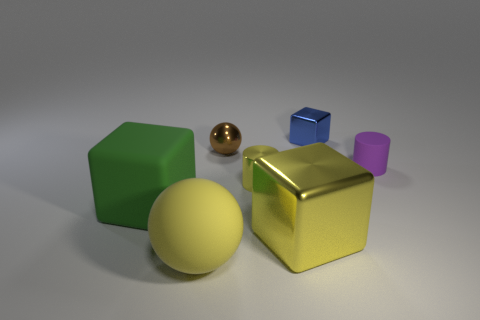What size is the ball that is the same material as the green cube?
Your answer should be compact. Large. Do the matte ball and the small shiny cylinder have the same color?
Ensure brevity in your answer.  Yes. There is a tiny thing behind the small brown metallic ball; is its shape the same as the big yellow shiny thing?
Your response must be concise. Yes. How many other gray blocks have the same size as the rubber cube?
Your answer should be very brief. 0. What is the shape of the matte thing that is the same color as the shiny cylinder?
Give a very brief answer. Sphere. Is there a big cube to the right of the cylinder left of the tiny metallic block?
Your answer should be very brief. Yes. What number of things are yellow things that are right of the brown ball or big yellow matte balls?
Make the answer very short. 3. What number of red blocks are there?
Your response must be concise. 0. There is a brown object that is the same material as the blue thing; what is its shape?
Give a very brief answer. Sphere. How big is the ball behind the ball on the left side of the small brown metallic ball?
Offer a terse response. Small. 